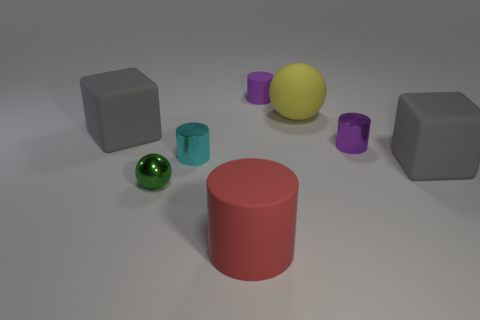Subtract all tiny purple matte cylinders. How many cylinders are left? 3 Add 1 big brown metallic objects. How many objects exist? 9 Subtract all balls. How many objects are left? 6 Subtract 0 yellow cylinders. How many objects are left? 8 Subtract 2 blocks. How many blocks are left? 0 Subtract all cyan cylinders. Subtract all brown blocks. How many cylinders are left? 3 Subtract all gray cylinders. How many green balls are left? 1 Subtract all metallic things. Subtract all purple cylinders. How many objects are left? 3 Add 3 green objects. How many green objects are left? 4 Add 1 big yellow matte things. How many big yellow matte things exist? 2 